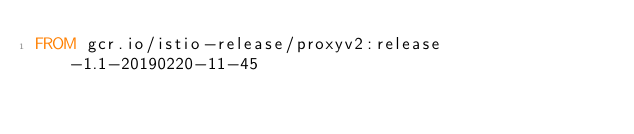Convert code to text. <code><loc_0><loc_0><loc_500><loc_500><_Dockerfile_>FROM gcr.io/istio-release/proxyv2:release-1.1-20190220-11-45
</code> 